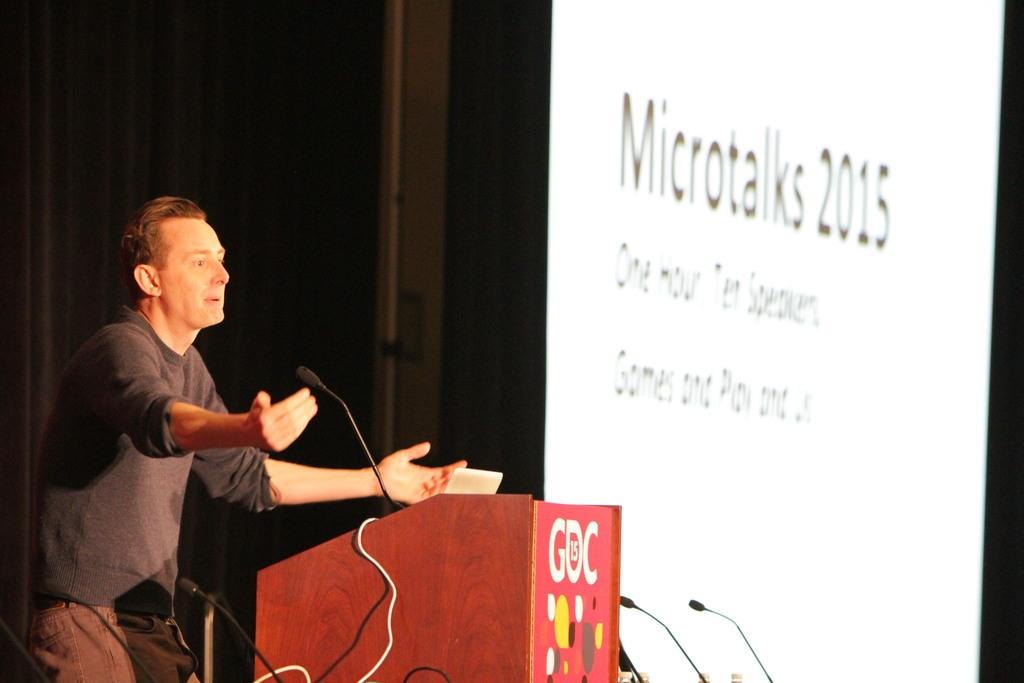What is the man in the image doing? The man is standing in the image. What is in front of the man? There is a podium and microphones in front of the man. What can be seen connected to the microphones? Cables are visible in the image. What is visible in the background of the image? There is a screen and other objects present in the background of the image. What type of boats are depicted on the map in the image? There is no map or boats present in the image. What is the title of the book on the table in the image? There is no book or table present in the image. 